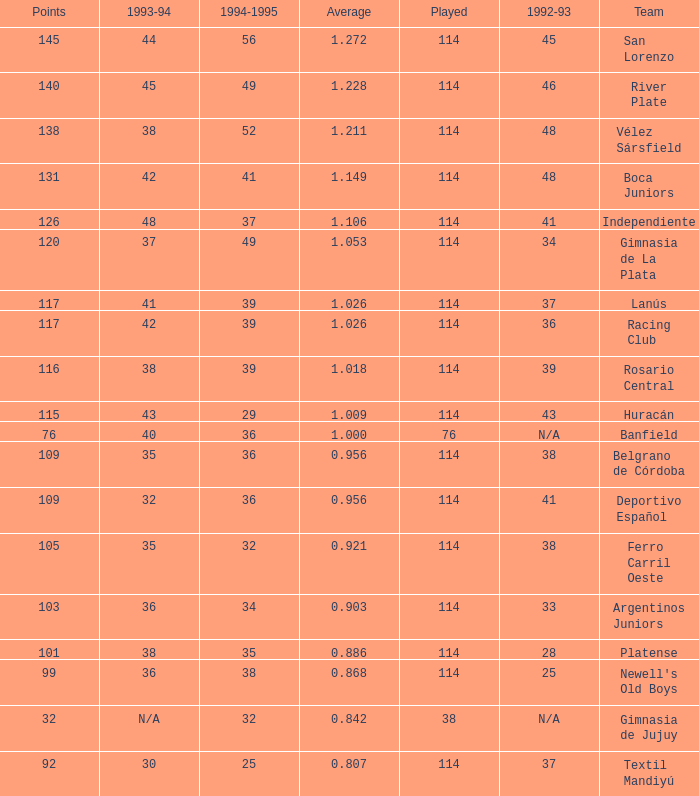Name the most played 114.0. 